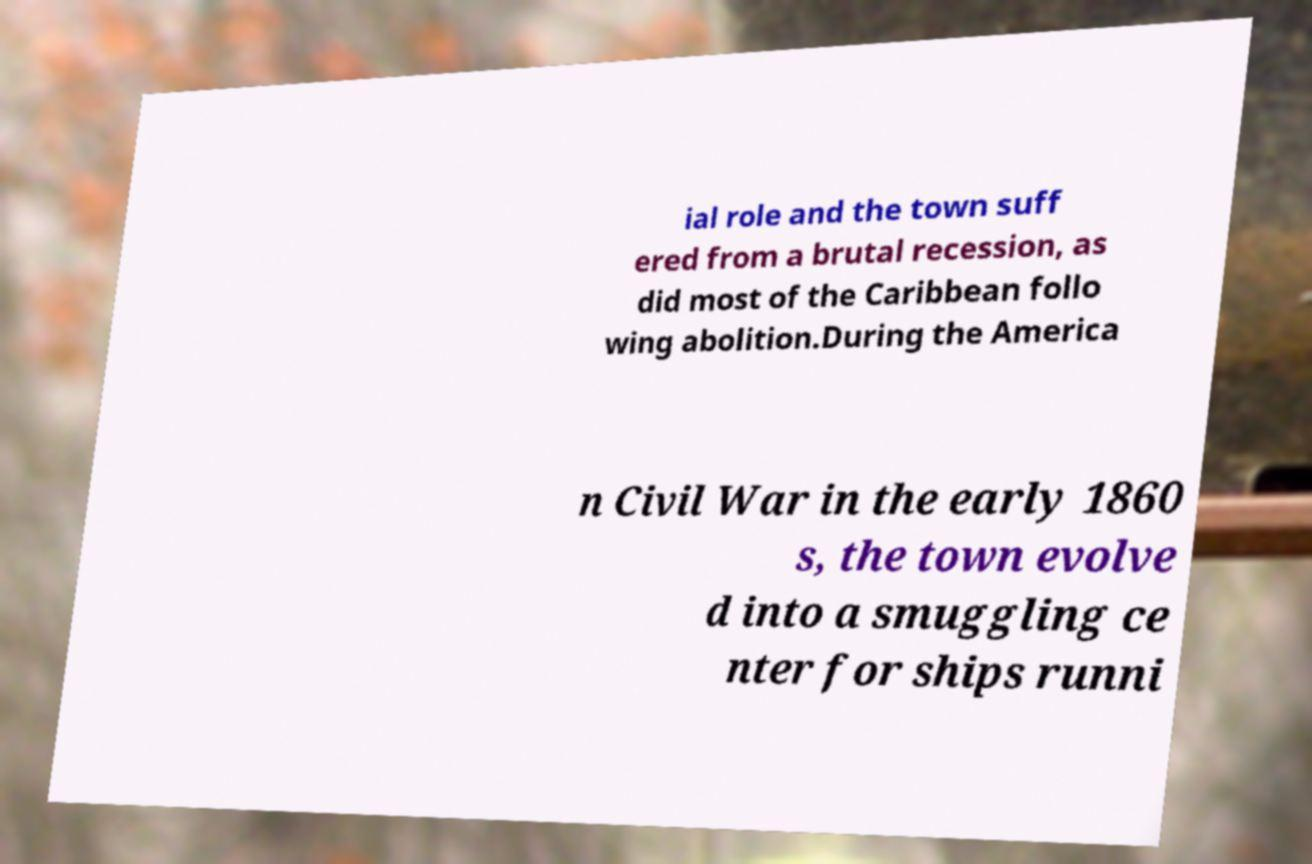What messages or text are displayed in this image? I need them in a readable, typed format. ial role and the town suff ered from a brutal recession, as did most of the Caribbean follo wing abolition.During the America n Civil War in the early 1860 s, the town evolve d into a smuggling ce nter for ships runni 